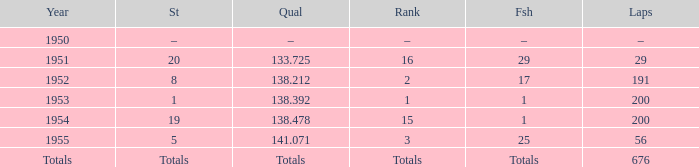What finish qualified at 141.071? 25.0. Write the full table. {'header': ['Year', 'St', 'Qual', 'Rank', 'Fsh', 'Laps'], 'rows': [['1950', '–', '–', '–', '–', '–'], ['1951', '20', '133.725', '16', '29', '29'], ['1952', '8', '138.212', '2', '17', '191'], ['1953', '1', '138.392', '1', '1', '200'], ['1954', '19', '138.478', '15', '1', '200'], ['1955', '5', '141.071', '3', '25', '56'], ['Totals', 'Totals', 'Totals', 'Totals', 'Totals', '676']]} 